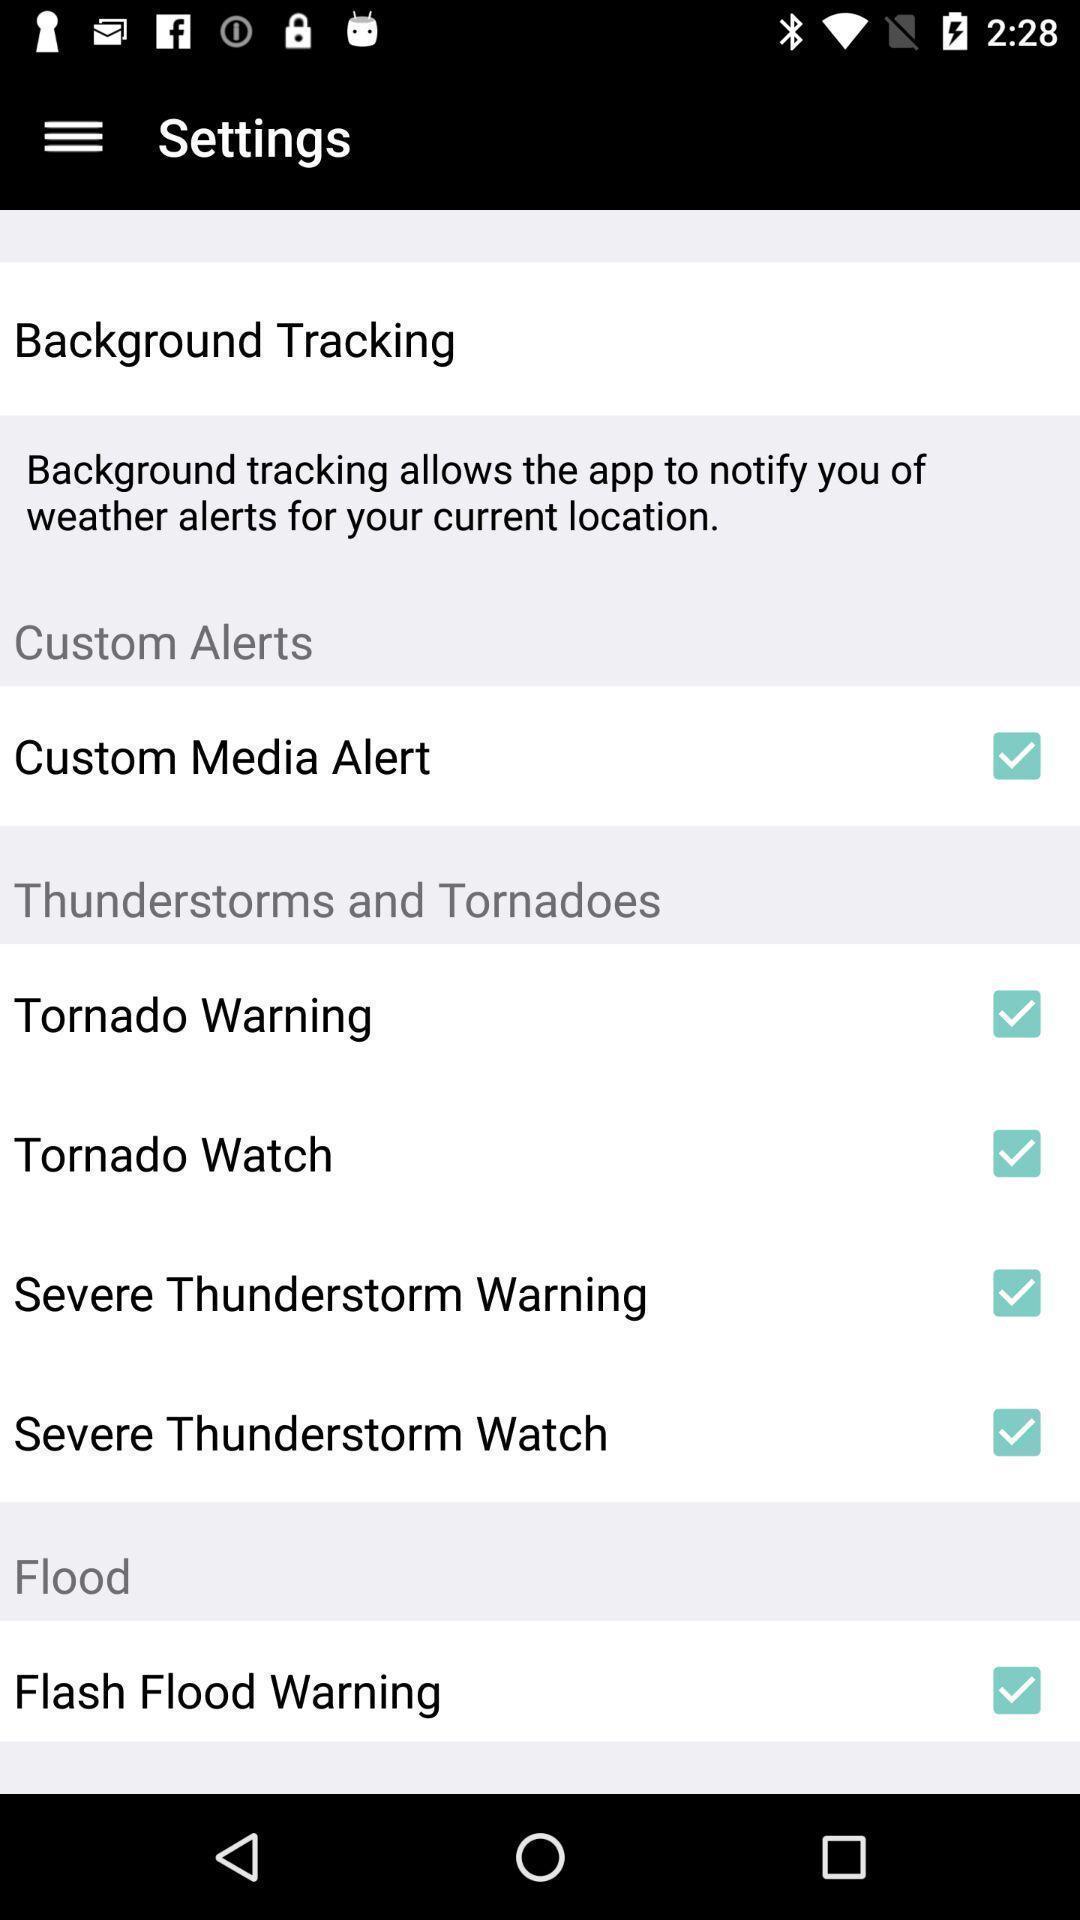What can you discern from this picture? Screen shows setting in a weather app. 